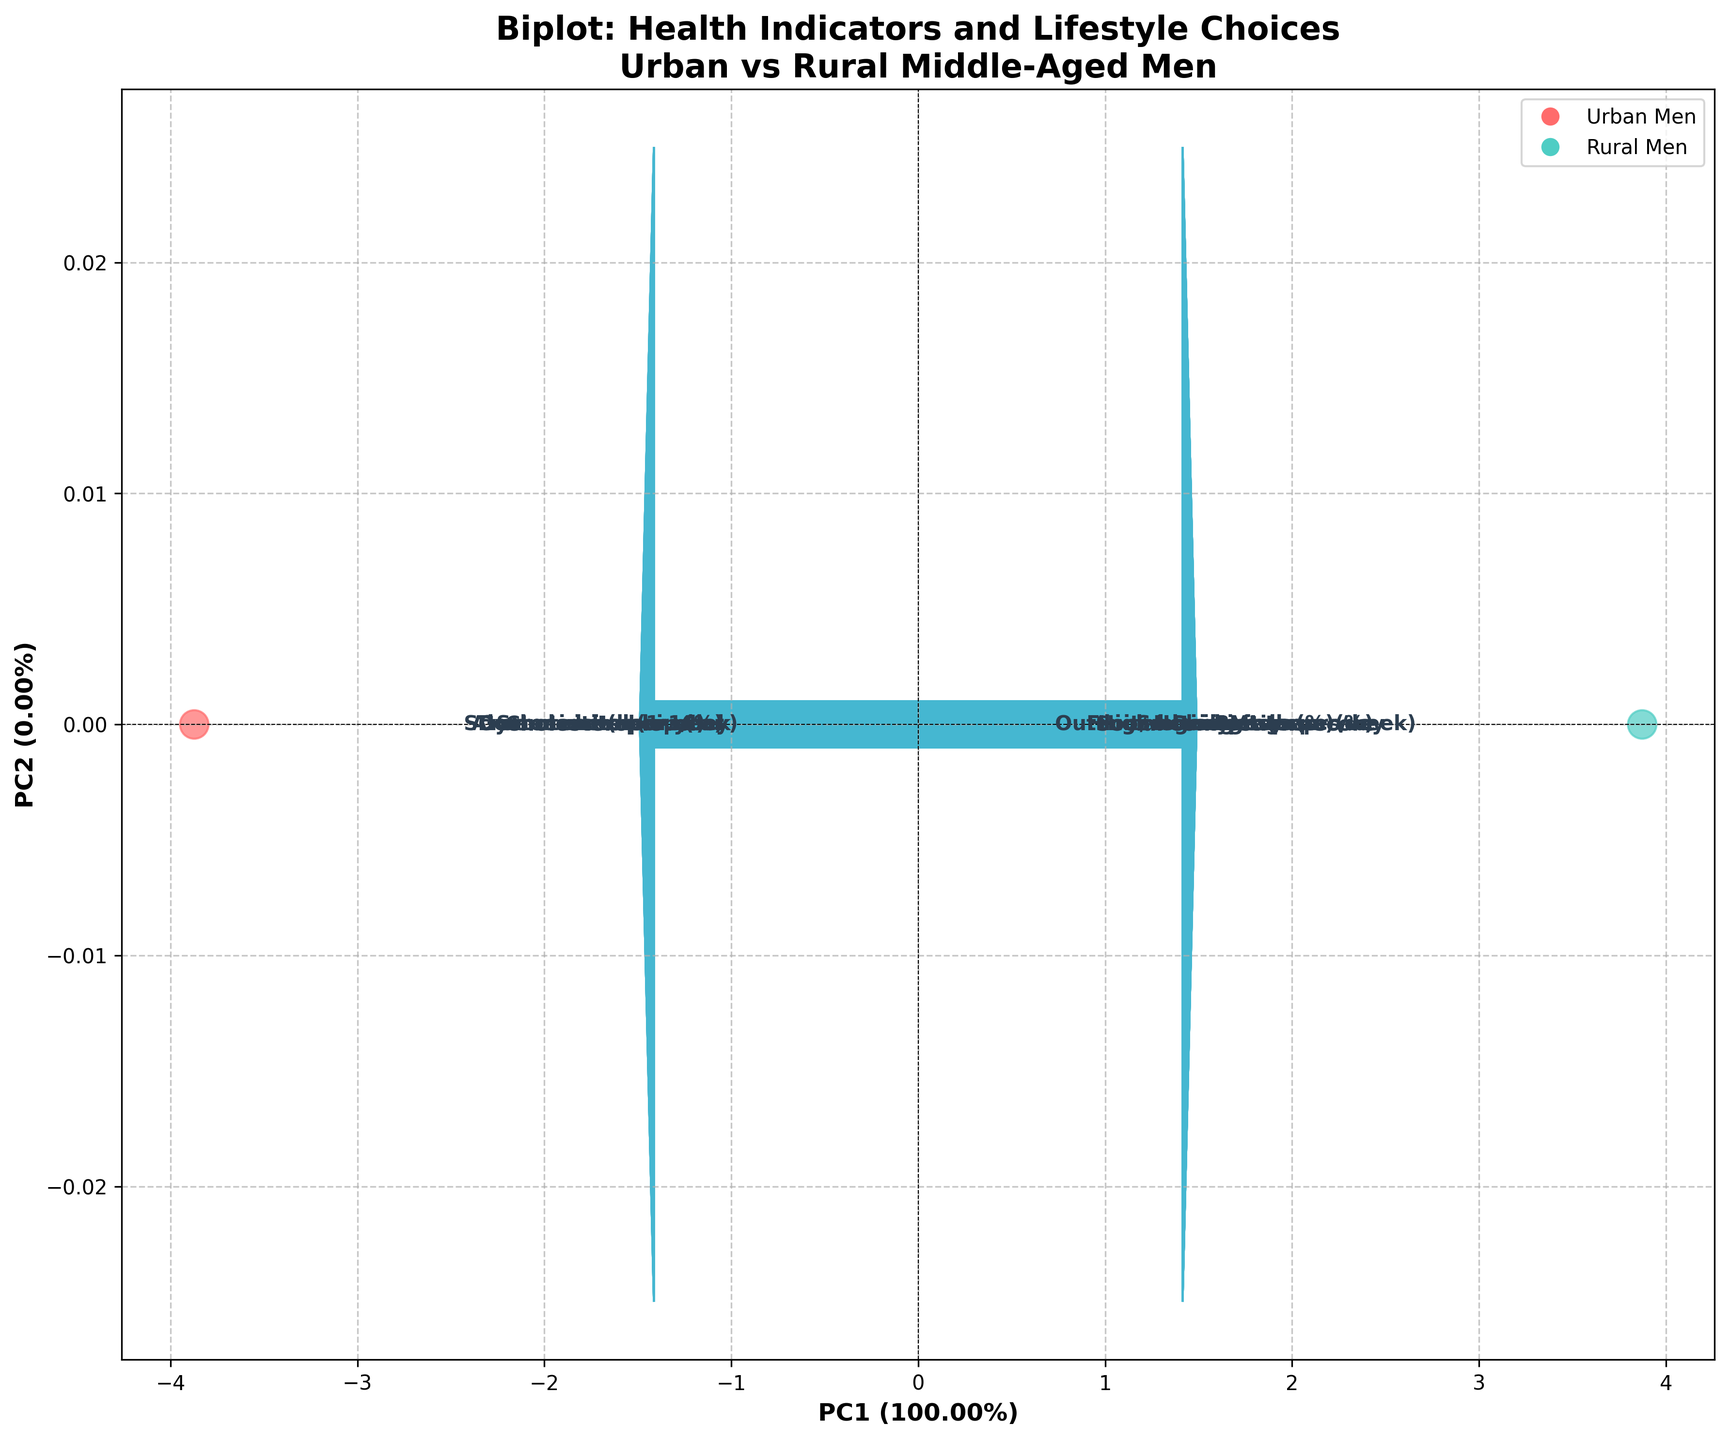What does the title of the plot indicate? The title "Biplot: Health Indicators and Lifestyle Choices Urban vs Rural Middle-Aged Men" indicates that the plot compares health indicators and lifestyle choices between middle-aged men living in urban and rural areas.
Answer: Comparison of health indicators and lifestyle choices What do the X and Y axes represent in the plot? The X-axis and Y-axis represent the first two principal components (PC1 and PC2) from the PCA, which capture the most variance in the data.
Answer: PC1 and PC2 How many data points are there in the plot, and what do they represent? There are two data points in the plot, represented by circles. They correspond to the health indicators and lifestyle choices of urban men and rural men.
Answer: Two data points Which group has a higher score on social connections according to the biplot? By looking at the loading vector corresponding to "Social connections score," rural men have a higher score as the vector points closer to the data point for rural men.
Answer: Rural men Which variable seems to have the highest influence on distinguishing between urban and rural men along PC1? By observing the length and direction of the loading vectors along PC1, variables like "Social connections score" and "Stress level (1-10)" seem to have a strong influence on distinguishing between urban and rural men.
Answer: Social connections score and Stress level (1-10) What is the percentage of explained variance by PC1 and PC2 combined? By looking at the axis labels, you can see the percentage of variance explained by PC1 and PC2. Summing them up, if PC1 explains 30% and PC2 explains 20%, the total explained variance would be 50%.
Answer: Sum of both percentages from axis labels Which habit-related variables are strongly associated with rural men? The loading vectors for "Daily steps," "Fruit/veg servings per day," and "Outdoor activities (hours/week)" are closer to the data point for rural men, indicating a strong association.
Answer: Daily steps, Fruit/veg servings per day, Outdoor activities Between urban and rural men, who reported higher stress levels? By looking at the loading vector for "Stress level (1-10)," it points closer to the data point for urban men, indicating higher reported stress levels.
Answer: Urban men What can we infer about gym memberships between urban and rural men from the biplot? The loading vector for "Gym membership (%)" points closer to the data point for urban men, suggesting a higher percentage of gym memberships among urban men.
Answer: Urban men In terms of alcohol consumption, how do urban men compare to rural men according to the biplot? The arrow for "Alcohol units per week" points closer to urban men, indicating that urban men consume more alcohol units per week than rural men.
Answer: Urban men 